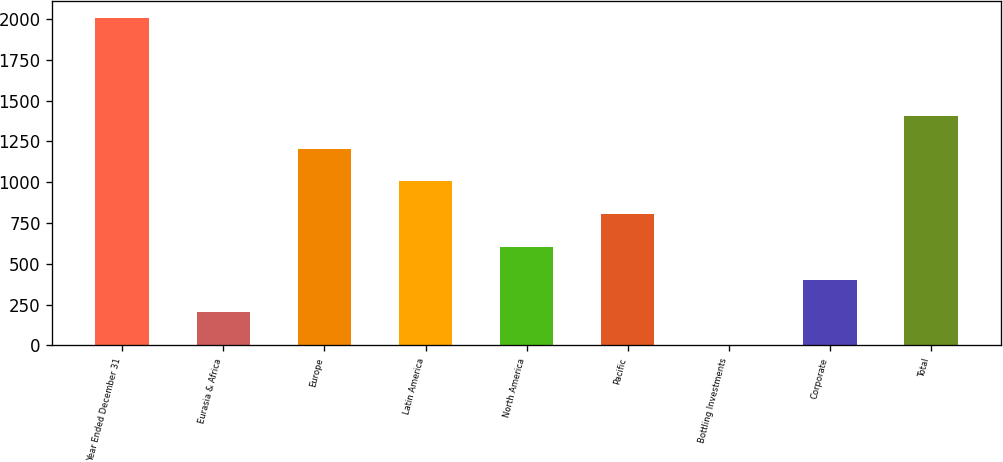Convert chart to OTSL. <chart><loc_0><loc_0><loc_500><loc_500><bar_chart><fcel>Year Ended December 31<fcel>Eurasia & Africa<fcel>Europe<fcel>Latin America<fcel>North America<fcel>Pacific<fcel>Bottling Investments<fcel>Corporate<fcel>Total<nl><fcel>2009<fcel>202.88<fcel>1206.28<fcel>1005.6<fcel>604.24<fcel>804.92<fcel>2.2<fcel>403.56<fcel>1406.96<nl></chart> 